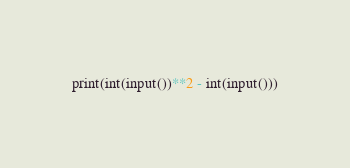<code> <loc_0><loc_0><loc_500><loc_500><_Python_>print(int(input())**2 - int(input()))</code> 